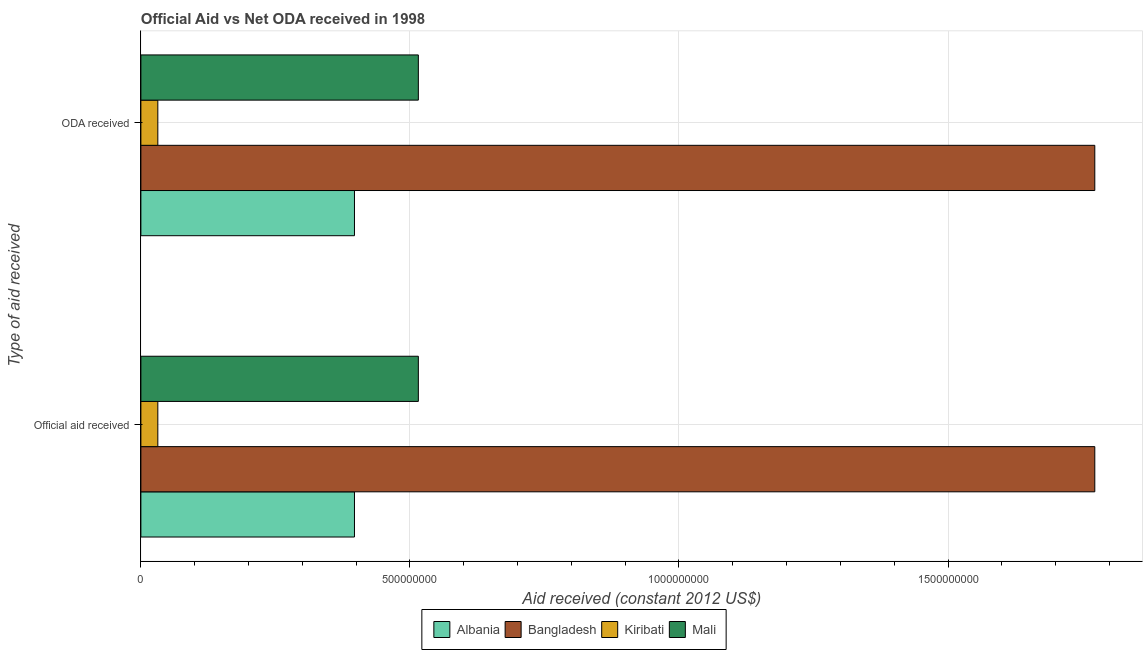How many groups of bars are there?
Your response must be concise. 2. Are the number of bars per tick equal to the number of legend labels?
Provide a succinct answer. Yes. Are the number of bars on each tick of the Y-axis equal?
Offer a terse response. Yes. How many bars are there on the 2nd tick from the bottom?
Give a very brief answer. 4. What is the label of the 1st group of bars from the top?
Offer a very short reply. ODA received. What is the oda received in Kiribati?
Make the answer very short. 3.15e+07. Across all countries, what is the maximum official aid received?
Give a very brief answer. 1.77e+09. Across all countries, what is the minimum oda received?
Make the answer very short. 3.15e+07. In which country was the official aid received maximum?
Keep it short and to the point. Bangladesh. In which country was the oda received minimum?
Give a very brief answer. Kiribati. What is the total oda received in the graph?
Your response must be concise. 2.72e+09. What is the difference between the official aid received in Mali and that in Bangladesh?
Provide a succinct answer. -1.26e+09. What is the difference between the oda received in Albania and the official aid received in Bangladesh?
Your answer should be very brief. -1.38e+09. What is the average official aid received per country?
Your answer should be compact. 6.79e+08. What is the difference between the oda received and official aid received in Kiribati?
Give a very brief answer. 0. In how many countries, is the oda received greater than 100000000 US$?
Ensure brevity in your answer.  3. What is the ratio of the oda received in Mali to that in Bangladesh?
Offer a very short reply. 0.29. What does the 3rd bar from the top in Official aid received represents?
Ensure brevity in your answer.  Bangladesh. What does the 4th bar from the bottom in ODA received represents?
Make the answer very short. Mali. How many bars are there?
Your response must be concise. 8. Are all the bars in the graph horizontal?
Make the answer very short. Yes. Does the graph contain grids?
Provide a succinct answer. Yes. Where does the legend appear in the graph?
Give a very brief answer. Bottom center. How many legend labels are there?
Offer a very short reply. 4. What is the title of the graph?
Make the answer very short. Official Aid vs Net ODA received in 1998 . Does "Congo (Republic)" appear as one of the legend labels in the graph?
Offer a very short reply. No. What is the label or title of the X-axis?
Your answer should be compact. Aid received (constant 2012 US$). What is the label or title of the Y-axis?
Offer a terse response. Type of aid received. What is the Aid received (constant 2012 US$) in Albania in Official aid received?
Provide a succinct answer. 3.97e+08. What is the Aid received (constant 2012 US$) in Bangladesh in Official aid received?
Ensure brevity in your answer.  1.77e+09. What is the Aid received (constant 2012 US$) of Kiribati in Official aid received?
Your answer should be compact. 3.15e+07. What is the Aid received (constant 2012 US$) of Mali in Official aid received?
Offer a terse response. 5.16e+08. What is the Aid received (constant 2012 US$) of Albania in ODA received?
Keep it short and to the point. 3.97e+08. What is the Aid received (constant 2012 US$) of Bangladesh in ODA received?
Offer a terse response. 1.77e+09. What is the Aid received (constant 2012 US$) in Kiribati in ODA received?
Offer a terse response. 3.15e+07. What is the Aid received (constant 2012 US$) of Mali in ODA received?
Provide a short and direct response. 5.16e+08. Across all Type of aid received, what is the maximum Aid received (constant 2012 US$) of Albania?
Give a very brief answer. 3.97e+08. Across all Type of aid received, what is the maximum Aid received (constant 2012 US$) of Bangladesh?
Provide a short and direct response. 1.77e+09. Across all Type of aid received, what is the maximum Aid received (constant 2012 US$) in Kiribati?
Ensure brevity in your answer.  3.15e+07. Across all Type of aid received, what is the maximum Aid received (constant 2012 US$) in Mali?
Offer a terse response. 5.16e+08. Across all Type of aid received, what is the minimum Aid received (constant 2012 US$) in Albania?
Provide a succinct answer. 3.97e+08. Across all Type of aid received, what is the minimum Aid received (constant 2012 US$) of Bangladesh?
Give a very brief answer. 1.77e+09. Across all Type of aid received, what is the minimum Aid received (constant 2012 US$) in Kiribati?
Make the answer very short. 3.15e+07. Across all Type of aid received, what is the minimum Aid received (constant 2012 US$) in Mali?
Provide a short and direct response. 5.16e+08. What is the total Aid received (constant 2012 US$) in Albania in the graph?
Your response must be concise. 7.94e+08. What is the total Aid received (constant 2012 US$) in Bangladesh in the graph?
Your answer should be compact. 3.55e+09. What is the total Aid received (constant 2012 US$) of Kiribati in the graph?
Your response must be concise. 6.30e+07. What is the total Aid received (constant 2012 US$) of Mali in the graph?
Your answer should be compact. 1.03e+09. What is the difference between the Aid received (constant 2012 US$) in Albania in Official aid received and the Aid received (constant 2012 US$) in Bangladesh in ODA received?
Offer a very short reply. -1.38e+09. What is the difference between the Aid received (constant 2012 US$) in Albania in Official aid received and the Aid received (constant 2012 US$) in Kiribati in ODA received?
Keep it short and to the point. 3.65e+08. What is the difference between the Aid received (constant 2012 US$) in Albania in Official aid received and the Aid received (constant 2012 US$) in Mali in ODA received?
Your response must be concise. -1.19e+08. What is the difference between the Aid received (constant 2012 US$) of Bangladesh in Official aid received and the Aid received (constant 2012 US$) of Kiribati in ODA received?
Give a very brief answer. 1.74e+09. What is the difference between the Aid received (constant 2012 US$) of Bangladesh in Official aid received and the Aid received (constant 2012 US$) of Mali in ODA received?
Provide a succinct answer. 1.26e+09. What is the difference between the Aid received (constant 2012 US$) in Kiribati in Official aid received and the Aid received (constant 2012 US$) in Mali in ODA received?
Your answer should be very brief. -4.84e+08. What is the average Aid received (constant 2012 US$) of Albania per Type of aid received?
Make the answer very short. 3.97e+08. What is the average Aid received (constant 2012 US$) of Bangladesh per Type of aid received?
Give a very brief answer. 1.77e+09. What is the average Aid received (constant 2012 US$) of Kiribati per Type of aid received?
Keep it short and to the point. 3.15e+07. What is the average Aid received (constant 2012 US$) of Mali per Type of aid received?
Ensure brevity in your answer.  5.16e+08. What is the difference between the Aid received (constant 2012 US$) in Albania and Aid received (constant 2012 US$) in Bangladesh in Official aid received?
Provide a succinct answer. -1.38e+09. What is the difference between the Aid received (constant 2012 US$) in Albania and Aid received (constant 2012 US$) in Kiribati in Official aid received?
Your response must be concise. 3.65e+08. What is the difference between the Aid received (constant 2012 US$) in Albania and Aid received (constant 2012 US$) in Mali in Official aid received?
Your answer should be very brief. -1.19e+08. What is the difference between the Aid received (constant 2012 US$) of Bangladesh and Aid received (constant 2012 US$) of Kiribati in Official aid received?
Make the answer very short. 1.74e+09. What is the difference between the Aid received (constant 2012 US$) of Bangladesh and Aid received (constant 2012 US$) of Mali in Official aid received?
Provide a short and direct response. 1.26e+09. What is the difference between the Aid received (constant 2012 US$) in Kiribati and Aid received (constant 2012 US$) in Mali in Official aid received?
Provide a short and direct response. -4.84e+08. What is the difference between the Aid received (constant 2012 US$) in Albania and Aid received (constant 2012 US$) in Bangladesh in ODA received?
Provide a short and direct response. -1.38e+09. What is the difference between the Aid received (constant 2012 US$) of Albania and Aid received (constant 2012 US$) of Kiribati in ODA received?
Offer a terse response. 3.65e+08. What is the difference between the Aid received (constant 2012 US$) of Albania and Aid received (constant 2012 US$) of Mali in ODA received?
Keep it short and to the point. -1.19e+08. What is the difference between the Aid received (constant 2012 US$) in Bangladesh and Aid received (constant 2012 US$) in Kiribati in ODA received?
Ensure brevity in your answer.  1.74e+09. What is the difference between the Aid received (constant 2012 US$) in Bangladesh and Aid received (constant 2012 US$) in Mali in ODA received?
Provide a short and direct response. 1.26e+09. What is the difference between the Aid received (constant 2012 US$) in Kiribati and Aid received (constant 2012 US$) in Mali in ODA received?
Provide a succinct answer. -4.84e+08. What is the ratio of the Aid received (constant 2012 US$) in Kiribati in Official aid received to that in ODA received?
Your answer should be compact. 1. What is the ratio of the Aid received (constant 2012 US$) of Mali in Official aid received to that in ODA received?
Offer a very short reply. 1. What is the difference between the highest and the second highest Aid received (constant 2012 US$) in Bangladesh?
Your response must be concise. 0. What is the difference between the highest and the second highest Aid received (constant 2012 US$) of Mali?
Ensure brevity in your answer.  0. What is the difference between the highest and the lowest Aid received (constant 2012 US$) in Albania?
Keep it short and to the point. 0. 